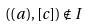Convert formula to latex. <formula><loc_0><loc_0><loc_500><loc_500>( ( a ) , [ c ] ) \notin I</formula> 